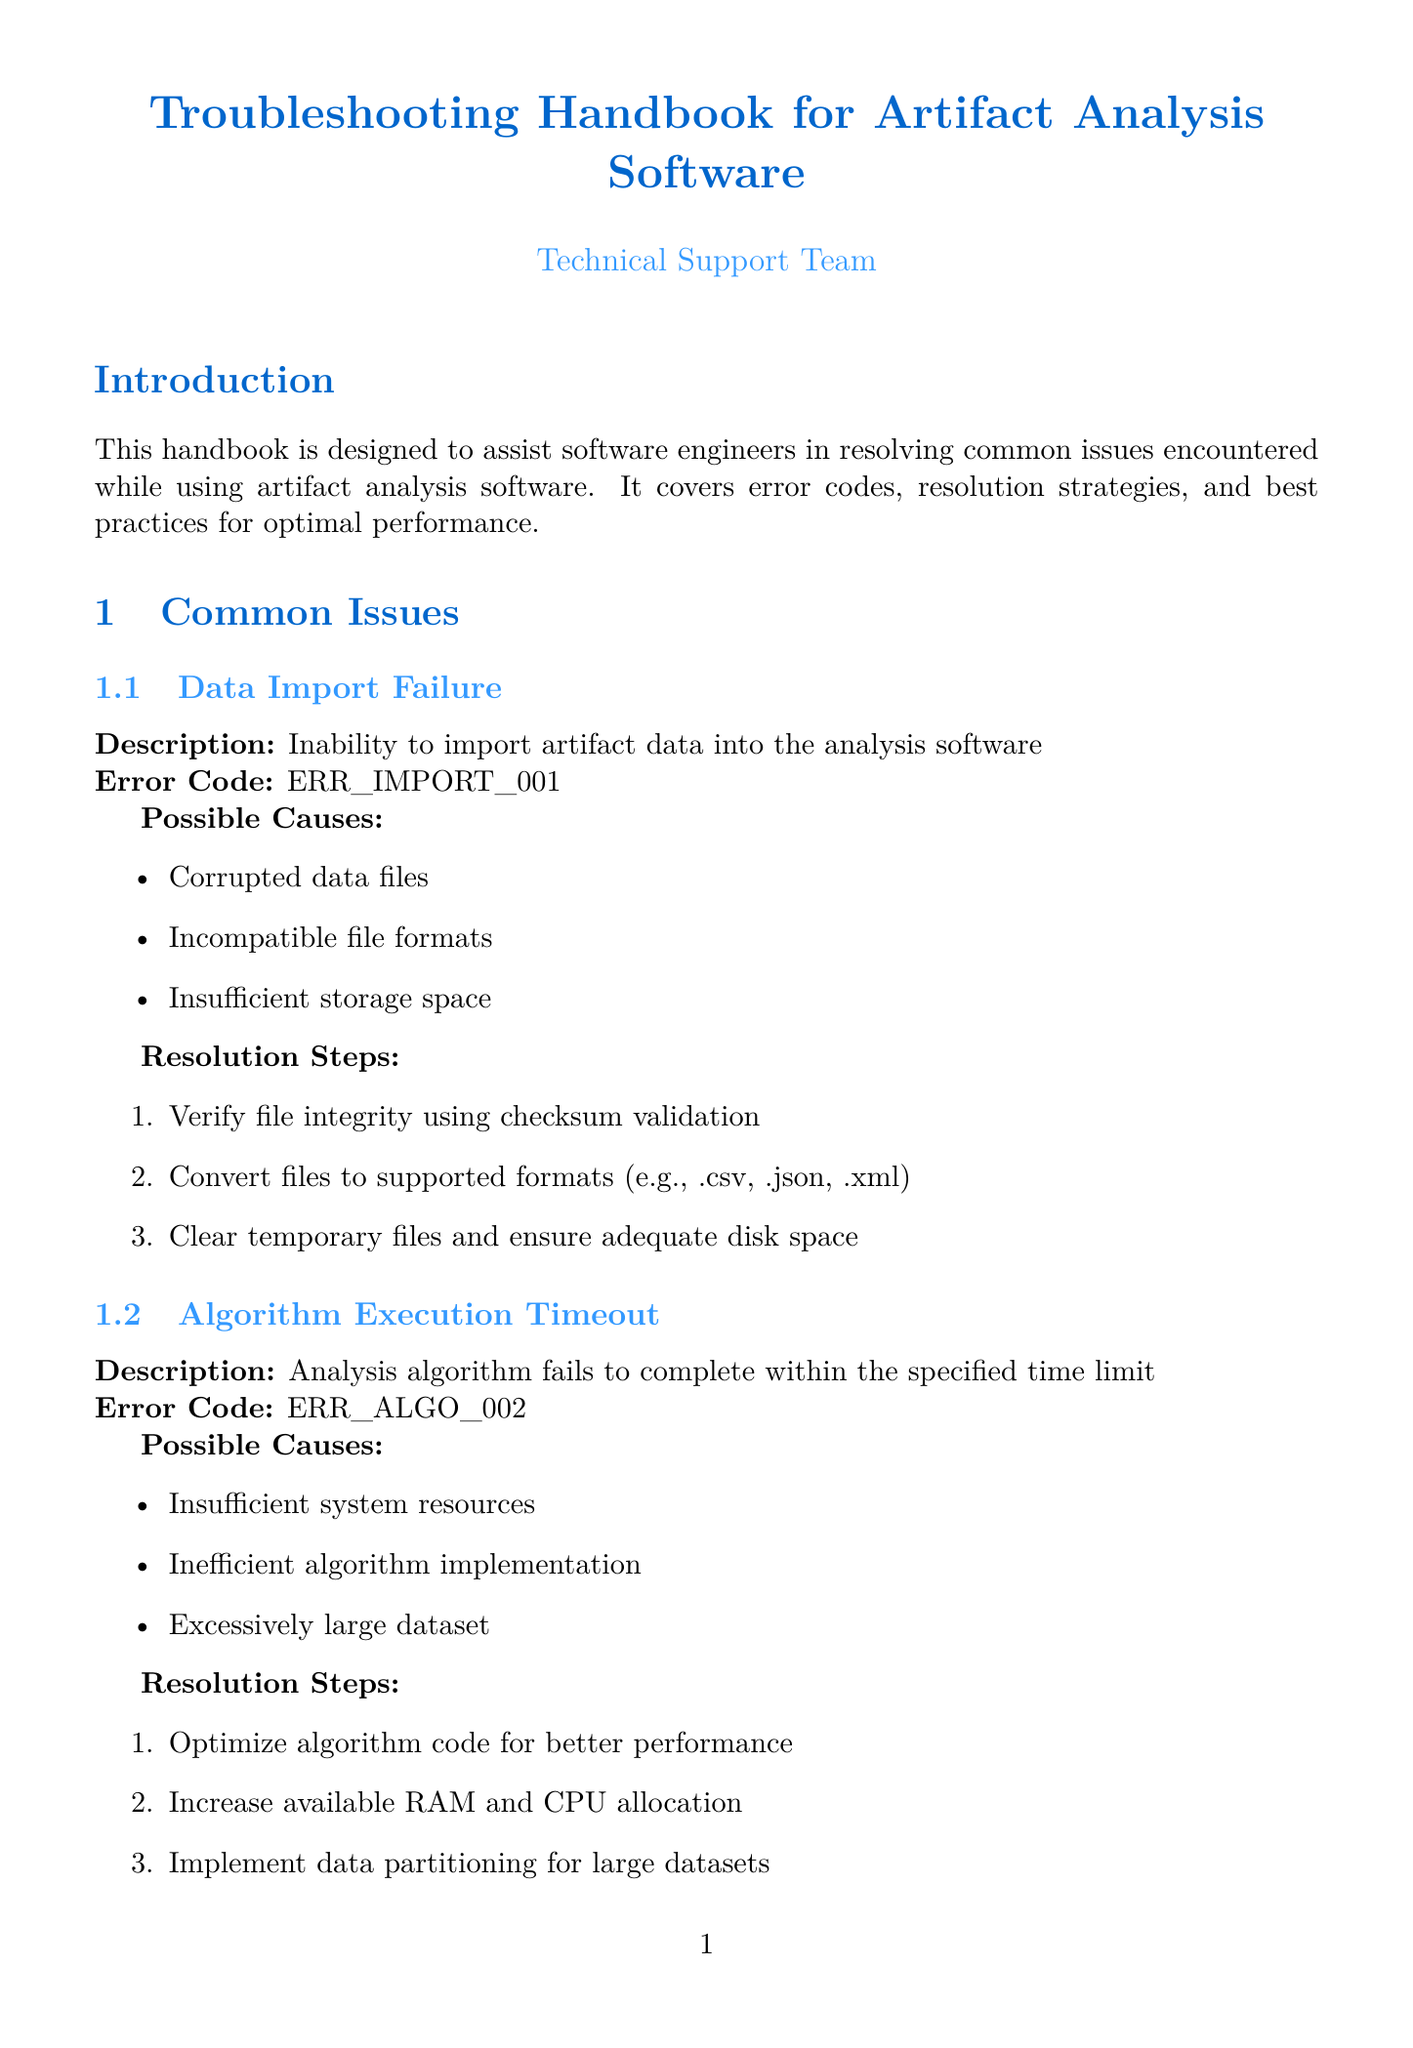what is the title of the handbook? The title of the handbook is located at the top, stating its purpose.
Answer: Troubleshooting Handbook for Artifact Analysis Software what is the error code for Data Import Failure? The error code is specified in the section describing the common issue for Data Import Failure.
Answer: ERR_IMPORT_001 which tool is mentioned for log analysis? The tools for log analysis are listed under the Advanced Troubleshooting section.
Answer: ELK Stack (Elasticsearch, Logstash, Kibana) what is one possible cause of Algorithm Execution Timeout? Possible causes are enumerated in the Algorithm Execution Timeout section.
Answer: Insufficient system resources how many best practices are listed? The number of best practices is noted in the Best Practices section.
Answer: Five what version of TensorFlow is covered in the software-specific guide? The version is explicitly mentioned in the corresponding subsection of the guides.
Answer: 2.7.0 what is the main focus area of profiling? Focus areas of profiling are outlined in the Profiling subsection under Advanced Troubleshooting.
Answer: CPU usage what is the contact email for technical support? The contact information for technical support includes an email address.
Answer: tech.support@artifactanalysis.com what type of errors are common in PyTorch? Common issues are listed in the PyTorch software-specific guide section.
Answer: CUDA compatibility issues 